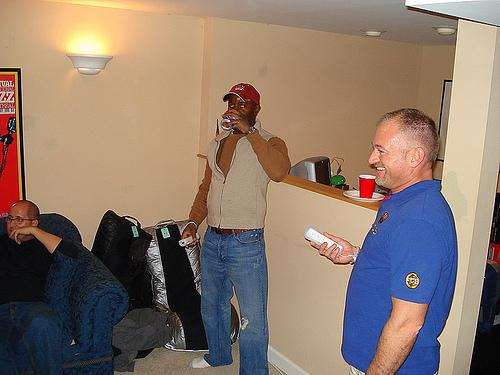What happen to the eyes of the man who is drinking?

Choices:
A) wearing makeup
B) blindness
C) light reflection
D) closed eyes light reflection 